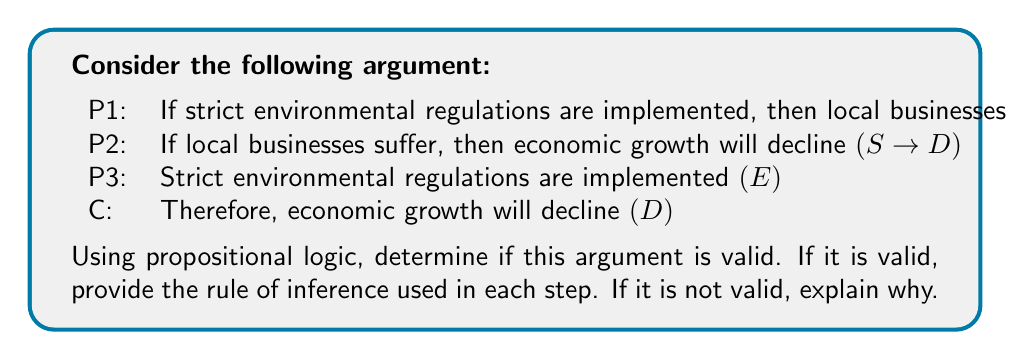Give your solution to this math problem. Let's analyze this argument step-by-step using propositional logic:

1) First, let's identify our propositions:
   E: Strict environmental regulations are implemented
   S: Local businesses will suffer
   D: Economic growth will decline

2) Now, let's write out our premises and conclusion in symbolic form:
   P1: E → S
   P2: S → D
   P3: E
   C: D

3) To prove validity, we need to show that the conclusion logically follows from the premises. We can do this using rules of inference:

   Step 1: E → S (Given, P1)
   Step 2: E (Given, P3)
   Step 3: S (Modus Ponens on steps 1 and 2)

   Step 4: S → D (Given, P2)
   Step 5: S (From step 3)
   Step 6: D (Modus Ponens on steps 4 and 5)

4) We've arrived at our conclusion D using valid logical steps. The argument is therefore valid.

5) The rules of inference used were:
   - Modus Ponens (twice): If P → Q and P is true, then Q must be true.

This argument demonstrates a chain of logical reasoning that a policy maker might encounter when considering the potential impacts of environmental regulations on local business growth and overall economic performance.
Answer: Valid; Modus Ponens applied twice 